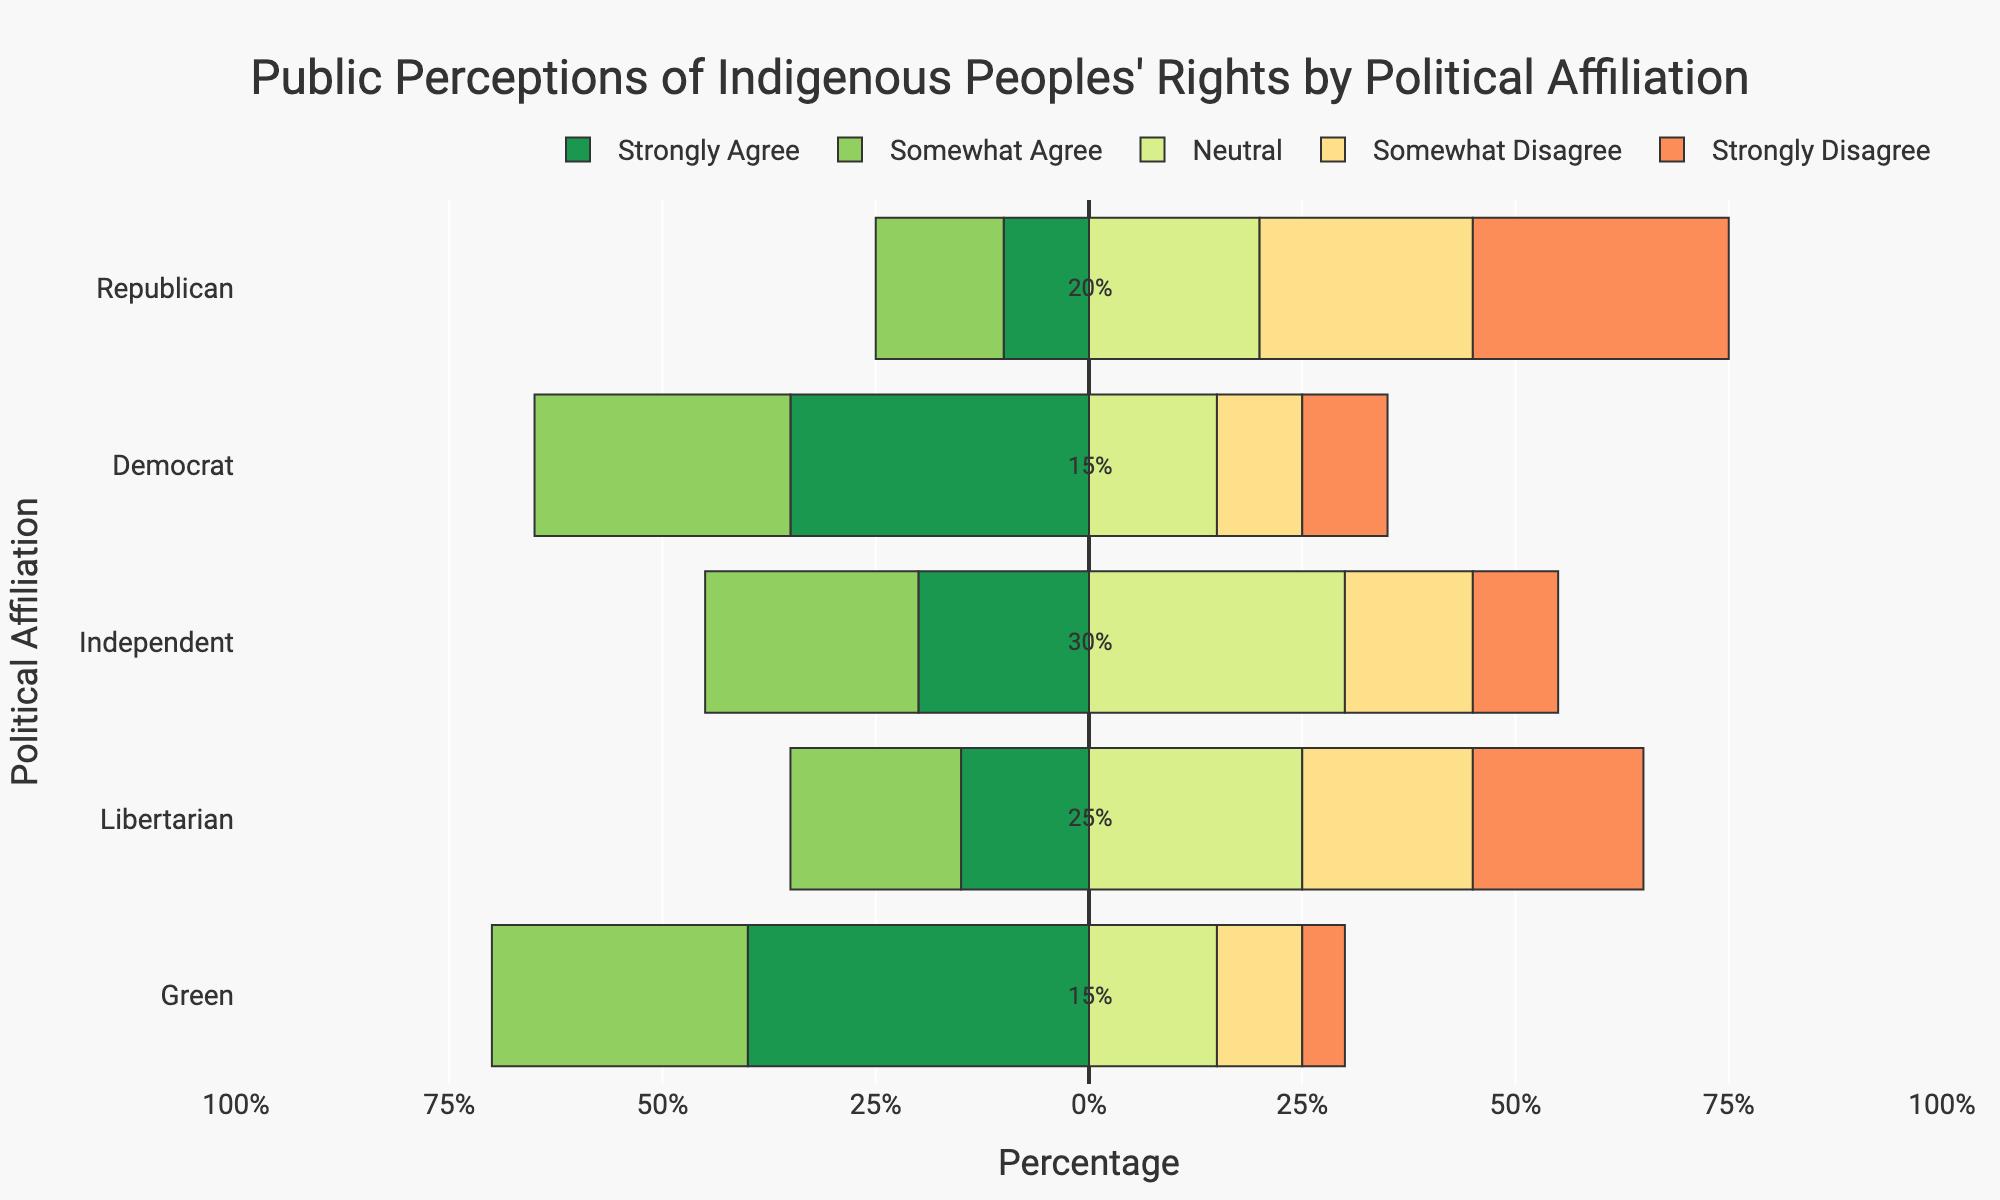What's the percentage of Republicans who either strongly agree or somewhat agree with Indigenous peoples' rights? Adding the percentages of Republicans who strongly agree (10%) and somewhat agree (15%) gives 10% + 15% = 25%.
Answer: 25% Which political affiliation has the highest percentage of neutral responses? The neutral percentages are: Republican (20%), Democrat (15%), Independent (30%), Libertarian (25%), Green (15%). Independent has the highest neutral percentage of 30%.
Answer: Independent How many more Democrats strongly agree with Indigenous peoples' rights compared to Republicans? The percentage of Democrats who strongly agree is 35%, and for Republicans, it's 10%. The difference is 35% - 10% = 25%.
Answer: 25% What is the total percentage of Libertarians who disagree (somewhat or strongly) with Indigenous peoples' rights? Adding the percentages of Libertarians who somewhat disagree (20%) and strongly disagree (20%) gives 20% + 20% = 40%.
Answer: 40% Compare the percentage of Greens who somewhat agree to the percentage of Republicans who somewhat agree. The percentage of Greens who somewhat agree is 30%, and the percentage of Republicans who somewhat agree is 15%. 30% is greater than 15%.
Answer: Green What percentage of Independents strongly disagree with Indigenous peoples' rights? The percentage of Independents who strongly disagree is 10%, directly read from the chart.
Answer: 10% Who has a higher percentage of strong disagreement, Republicans or Libertarians, and by how much? The percentage of Republicans who strongly disagree is 30%, and for Libertarians, it's 20%. The difference is 30% - 20% = 10%.
Answer: Republicans, 10% What's the total percentage of people who either strongly agree, somewhat agree, or are neutral among Democrats? Adding the percentages of Democrats who strongly agree (35%), somewhat agree (30%), and neutral (15%) gives 35% + 30% + 15% = 80%.
Answer: 80% Compare the sum of strong agreement and strong disagreement percentages between Independents and Greens. Which is higher? For Independents: Strongly agree (20%) + Strongly disagree (10%) = 30%. For Greens: Strongly agree (40%) + Strongly disagree (5%) = 45%. 45% is greater than 30%.
Answer: Green 